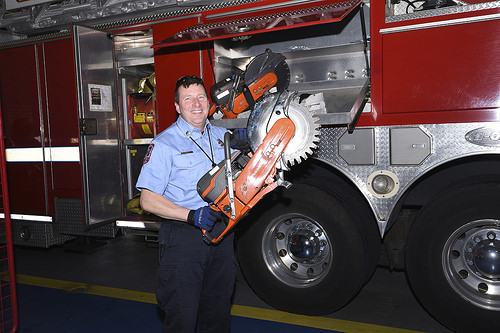<image>
Is there a man in the truck? No. The man is not contained within the truck. These objects have a different spatial relationship. 